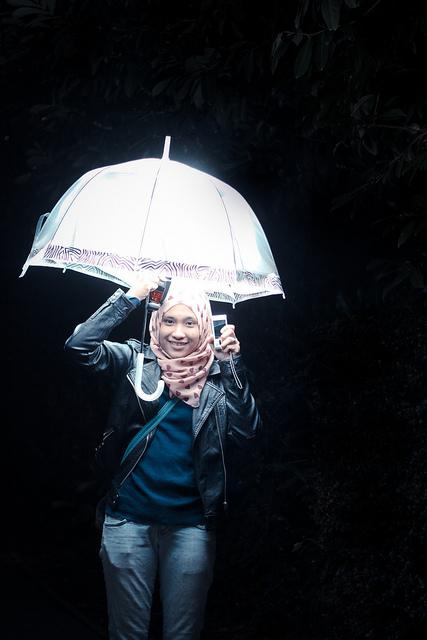Is her head covered?
Give a very brief answer. Yes. What color are the pants?
Keep it brief. Blue. Why is the umbrella so bright?
Concise answer only. Flash. 